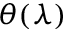<formula> <loc_0><loc_0><loc_500><loc_500>\theta ( \lambda )</formula> 